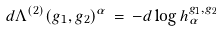<formula> <loc_0><loc_0><loc_500><loc_500>d \Lambda ^ { ( 2 ) } ( g _ { 1 } , g _ { 2 } ) ^ { \alpha } \, = \, - d \log h ^ { g _ { 1 } , g _ { 2 } } _ { \alpha }</formula> 